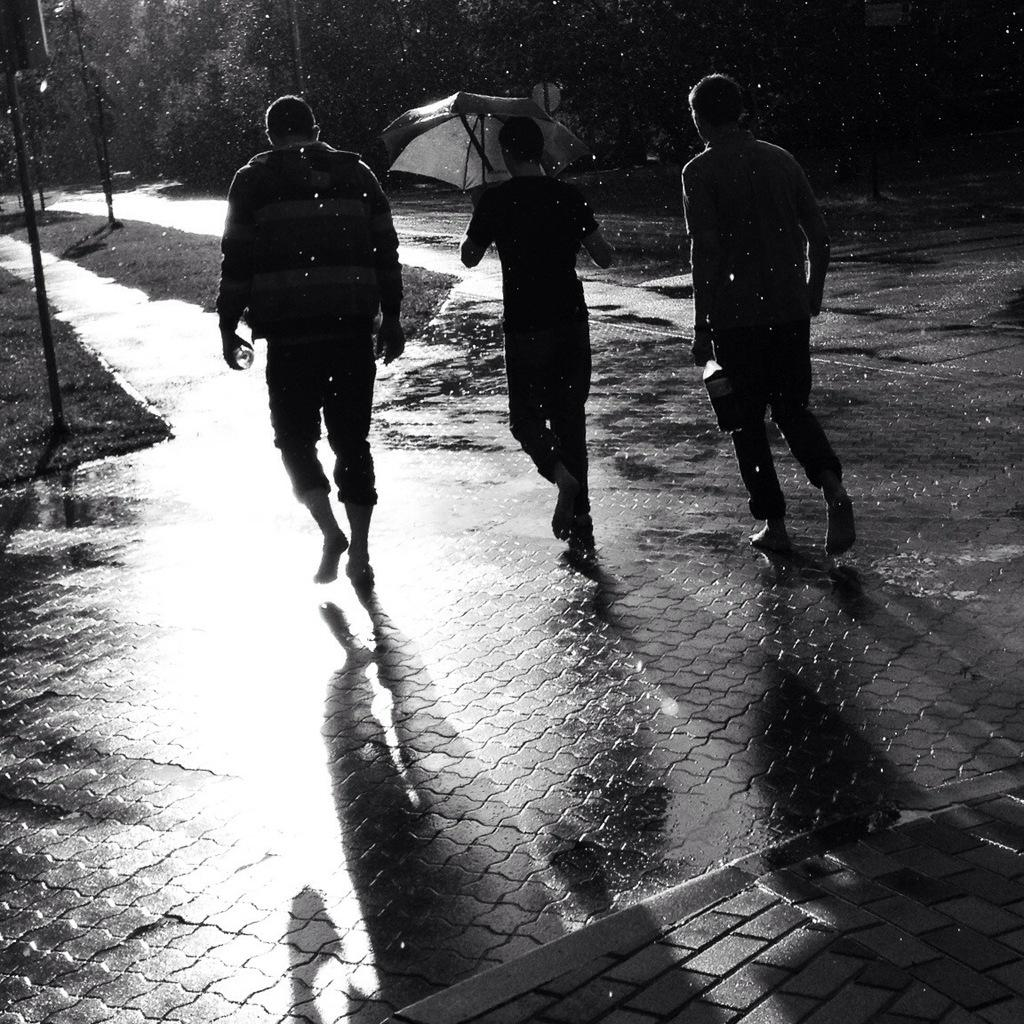What are the three persons in the image doing? The three persons are walking in the image. What can be seen in the background of the image? There are trees in the background of the image. What is present on the left side of the image? There are poles and grass on the left side of the image. What is the person in the middle holding? One person in the middle is holding an umbrella. How many gloves can be seen on the hands of the persons in the image? There are no gloves visible on the hands of the persons in the image. Are there any giants present in the image? There are no giants present in the image; the three persons walking are of normal size. 